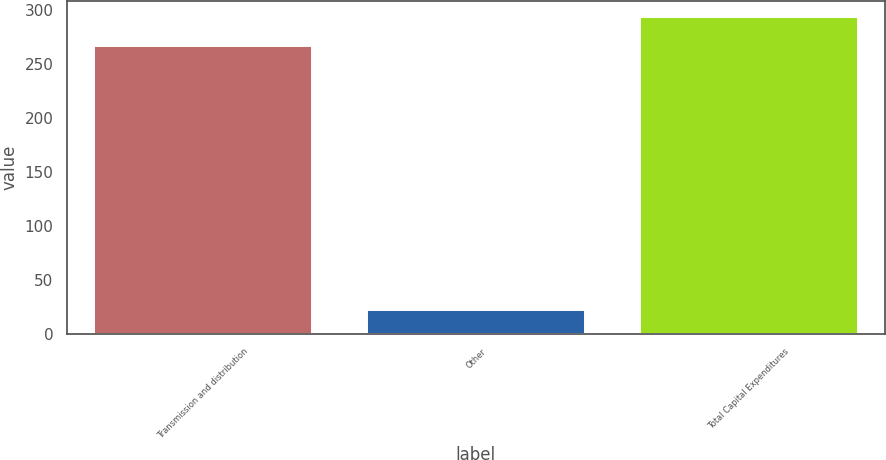Convert chart. <chart><loc_0><loc_0><loc_500><loc_500><bar_chart><fcel>Transmission and distribution<fcel>Other<fcel>Total Capital Expenditures<nl><fcel>267<fcel>22<fcel>293.7<nl></chart> 